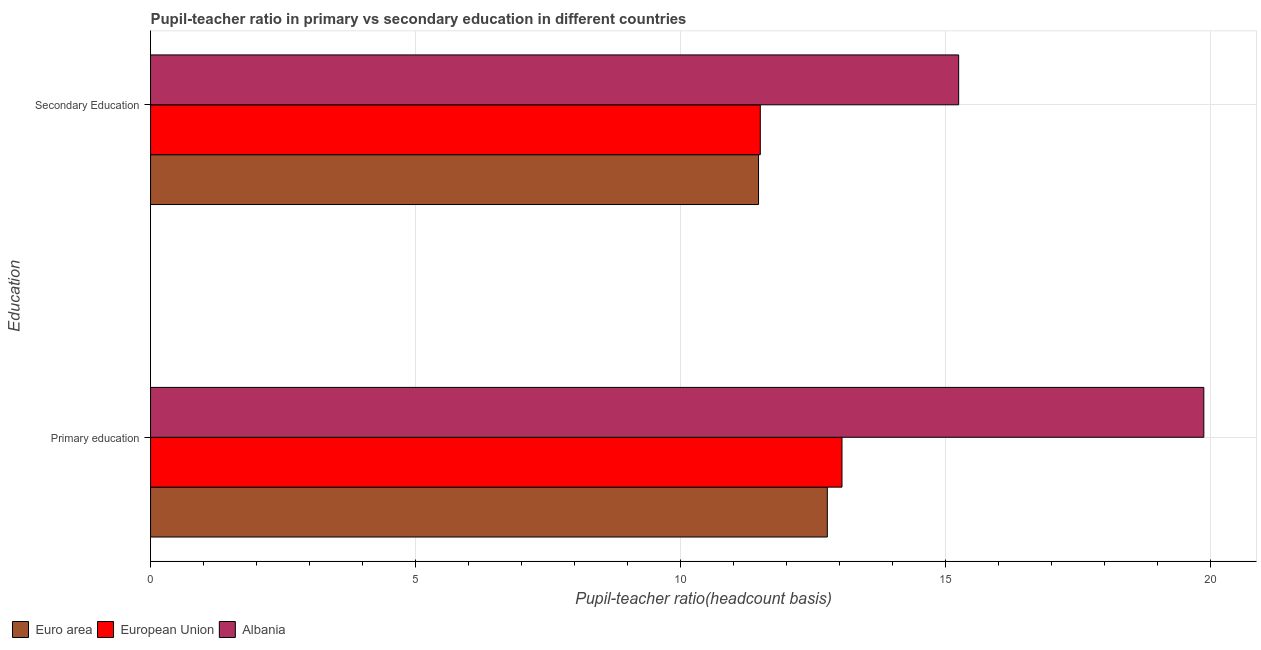How many different coloured bars are there?
Your response must be concise. 3. Are the number of bars per tick equal to the number of legend labels?
Make the answer very short. Yes. Are the number of bars on each tick of the Y-axis equal?
Give a very brief answer. Yes. How many bars are there on the 1st tick from the top?
Your answer should be compact. 3. What is the label of the 1st group of bars from the top?
Your answer should be compact. Secondary Education. What is the pupil teacher ratio on secondary education in Euro area?
Your response must be concise. 11.47. Across all countries, what is the maximum pupil teacher ratio on secondary education?
Give a very brief answer. 15.24. Across all countries, what is the minimum pupil teacher ratio on secondary education?
Ensure brevity in your answer.  11.47. In which country was the pupil teacher ratio on secondary education maximum?
Your response must be concise. Albania. In which country was the pupil-teacher ratio in primary education minimum?
Provide a short and direct response. Euro area. What is the total pupil-teacher ratio in primary education in the graph?
Your answer should be very brief. 45.68. What is the difference between the pupil-teacher ratio in primary education in Euro area and that in Albania?
Make the answer very short. -7.1. What is the difference between the pupil teacher ratio on secondary education in Albania and the pupil-teacher ratio in primary education in European Union?
Your answer should be very brief. 2.2. What is the average pupil teacher ratio on secondary education per country?
Provide a succinct answer. 12.74. What is the difference between the pupil-teacher ratio in primary education and pupil teacher ratio on secondary education in Albania?
Provide a short and direct response. 4.63. In how many countries, is the pupil-teacher ratio in primary education greater than 11 ?
Your answer should be very brief. 3. What is the ratio of the pupil teacher ratio on secondary education in Euro area to that in Albania?
Offer a terse response. 0.75. Is the pupil teacher ratio on secondary education in Albania less than that in European Union?
Your response must be concise. No. What does the 1st bar from the top in Secondary Education represents?
Your answer should be very brief. Albania. What does the 1st bar from the bottom in Primary education represents?
Give a very brief answer. Euro area. What is the difference between two consecutive major ticks on the X-axis?
Provide a succinct answer. 5. Are the values on the major ticks of X-axis written in scientific E-notation?
Your answer should be compact. No. Does the graph contain grids?
Your response must be concise. Yes. Where does the legend appear in the graph?
Keep it short and to the point. Bottom left. How are the legend labels stacked?
Your response must be concise. Horizontal. What is the title of the graph?
Make the answer very short. Pupil-teacher ratio in primary vs secondary education in different countries. Does "Canada" appear as one of the legend labels in the graph?
Offer a terse response. No. What is the label or title of the X-axis?
Keep it short and to the point. Pupil-teacher ratio(headcount basis). What is the label or title of the Y-axis?
Provide a succinct answer. Education. What is the Pupil-teacher ratio(headcount basis) in Euro area in Primary education?
Offer a terse response. 12.77. What is the Pupil-teacher ratio(headcount basis) of European Union in Primary education?
Ensure brevity in your answer.  13.04. What is the Pupil-teacher ratio(headcount basis) of Albania in Primary education?
Your answer should be compact. 19.87. What is the Pupil-teacher ratio(headcount basis) of Euro area in Secondary Education?
Ensure brevity in your answer.  11.47. What is the Pupil-teacher ratio(headcount basis) in European Union in Secondary Education?
Offer a very short reply. 11.5. What is the Pupil-teacher ratio(headcount basis) in Albania in Secondary Education?
Ensure brevity in your answer.  15.24. Across all Education, what is the maximum Pupil-teacher ratio(headcount basis) in Euro area?
Offer a terse response. 12.77. Across all Education, what is the maximum Pupil-teacher ratio(headcount basis) in European Union?
Your answer should be very brief. 13.04. Across all Education, what is the maximum Pupil-teacher ratio(headcount basis) of Albania?
Offer a terse response. 19.87. Across all Education, what is the minimum Pupil-teacher ratio(headcount basis) of Euro area?
Your response must be concise. 11.47. Across all Education, what is the minimum Pupil-teacher ratio(headcount basis) of European Union?
Offer a very short reply. 11.5. Across all Education, what is the minimum Pupil-teacher ratio(headcount basis) of Albania?
Provide a short and direct response. 15.24. What is the total Pupil-teacher ratio(headcount basis) of Euro area in the graph?
Keep it short and to the point. 24.24. What is the total Pupil-teacher ratio(headcount basis) of European Union in the graph?
Provide a short and direct response. 24.55. What is the total Pupil-teacher ratio(headcount basis) in Albania in the graph?
Provide a short and direct response. 35.11. What is the difference between the Pupil-teacher ratio(headcount basis) in Euro area in Primary education and that in Secondary Education?
Your answer should be very brief. 1.3. What is the difference between the Pupil-teacher ratio(headcount basis) in European Union in Primary education and that in Secondary Education?
Provide a succinct answer. 1.54. What is the difference between the Pupil-teacher ratio(headcount basis) of Albania in Primary education and that in Secondary Education?
Offer a terse response. 4.62. What is the difference between the Pupil-teacher ratio(headcount basis) of Euro area in Primary education and the Pupil-teacher ratio(headcount basis) of European Union in Secondary Education?
Your response must be concise. 1.26. What is the difference between the Pupil-teacher ratio(headcount basis) in Euro area in Primary education and the Pupil-teacher ratio(headcount basis) in Albania in Secondary Education?
Your answer should be compact. -2.48. What is the difference between the Pupil-teacher ratio(headcount basis) in European Union in Primary education and the Pupil-teacher ratio(headcount basis) in Albania in Secondary Education?
Offer a terse response. -2.2. What is the average Pupil-teacher ratio(headcount basis) of Euro area per Education?
Your response must be concise. 12.12. What is the average Pupil-teacher ratio(headcount basis) of European Union per Education?
Give a very brief answer. 12.27. What is the average Pupil-teacher ratio(headcount basis) in Albania per Education?
Ensure brevity in your answer.  17.56. What is the difference between the Pupil-teacher ratio(headcount basis) of Euro area and Pupil-teacher ratio(headcount basis) of European Union in Primary education?
Ensure brevity in your answer.  -0.28. What is the difference between the Pupil-teacher ratio(headcount basis) of Euro area and Pupil-teacher ratio(headcount basis) of Albania in Primary education?
Your answer should be very brief. -7.1. What is the difference between the Pupil-teacher ratio(headcount basis) of European Union and Pupil-teacher ratio(headcount basis) of Albania in Primary education?
Offer a very short reply. -6.83. What is the difference between the Pupil-teacher ratio(headcount basis) in Euro area and Pupil-teacher ratio(headcount basis) in European Union in Secondary Education?
Your answer should be compact. -0.03. What is the difference between the Pupil-teacher ratio(headcount basis) of Euro area and Pupil-teacher ratio(headcount basis) of Albania in Secondary Education?
Offer a terse response. -3.78. What is the difference between the Pupil-teacher ratio(headcount basis) in European Union and Pupil-teacher ratio(headcount basis) in Albania in Secondary Education?
Make the answer very short. -3.74. What is the ratio of the Pupil-teacher ratio(headcount basis) in Euro area in Primary education to that in Secondary Education?
Your answer should be very brief. 1.11. What is the ratio of the Pupil-teacher ratio(headcount basis) in European Union in Primary education to that in Secondary Education?
Provide a short and direct response. 1.13. What is the ratio of the Pupil-teacher ratio(headcount basis) in Albania in Primary education to that in Secondary Education?
Keep it short and to the point. 1.3. What is the difference between the highest and the second highest Pupil-teacher ratio(headcount basis) of Euro area?
Provide a short and direct response. 1.3. What is the difference between the highest and the second highest Pupil-teacher ratio(headcount basis) of European Union?
Offer a very short reply. 1.54. What is the difference between the highest and the second highest Pupil-teacher ratio(headcount basis) in Albania?
Make the answer very short. 4.62. What is the difference between the highest and the lowest Pupil-teacher ratio(headcount basis) in Euro area?
Your answer should be very brief. 1.3. What is the difference between the highest and the lowest Pupil-teacher ratio(headcount basis) in European Union?
Your response must be concise. 1.54. What is the difference between the highest and the lowest Pupil-teacher ratio(headcount basis) of Albania?
Your answer should be compact. 4.62. 